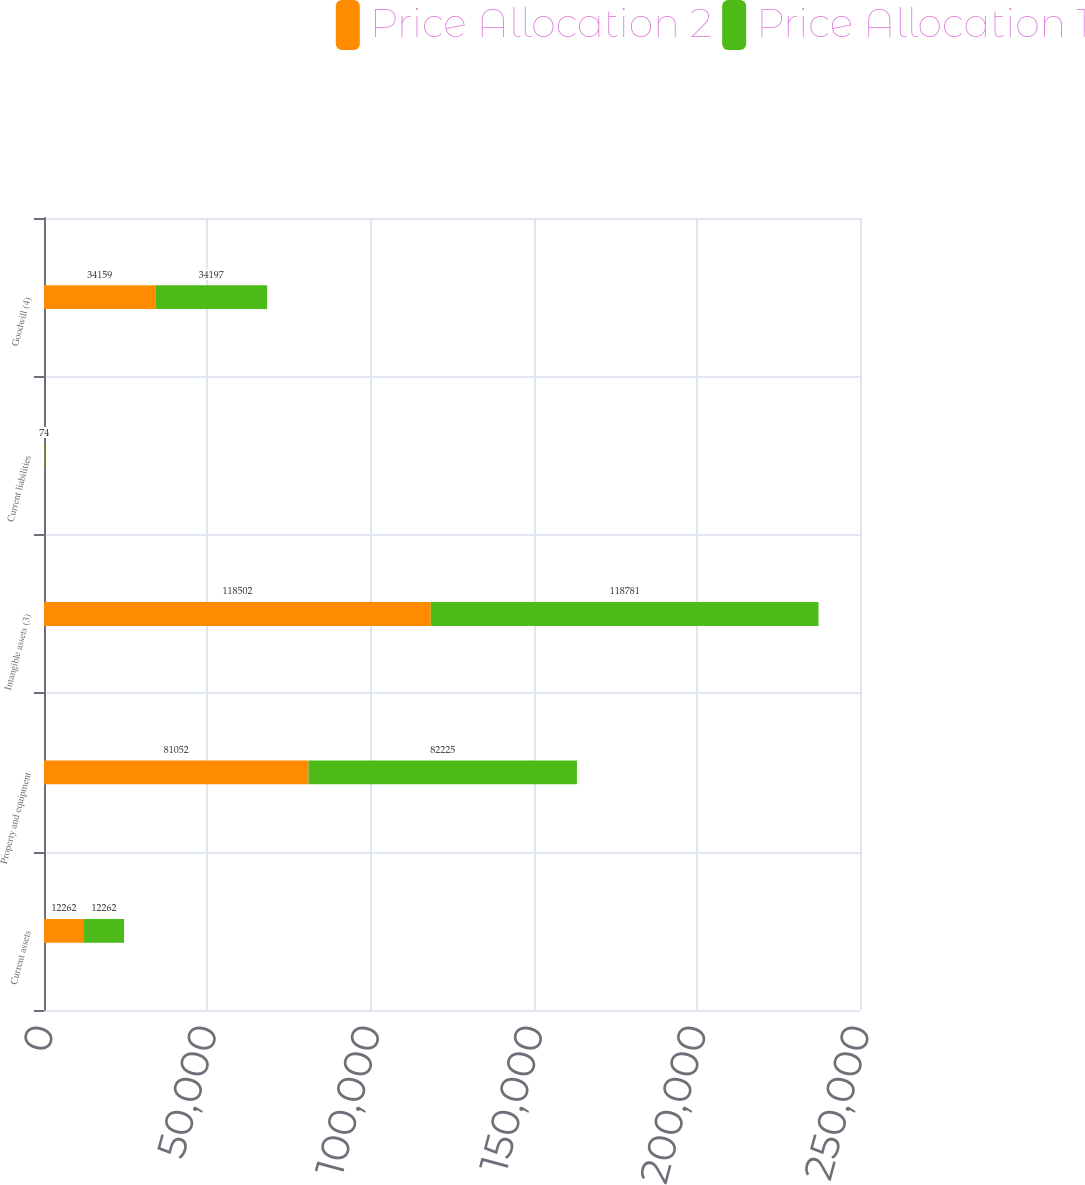Convert chart. <chart><loc_0><loc_0><loc_500><loc_500><stacked_bar_chart><ecel><fcel>Current assets<fcel>Property and equipment<fcel>Intangible assets (3)<fcel>Current liabilities<fcel>Goodwill (4)<nl><fcel>Price Allocation 2<fcel>12262<fcel>81052<fcel>118502<fcel>74<fcel>34159<nl><fcel>Price Allocation 1<fcel>12262<fcel>82225<fcel>118781<fcel>74<fcel>34197<nl></chart> 